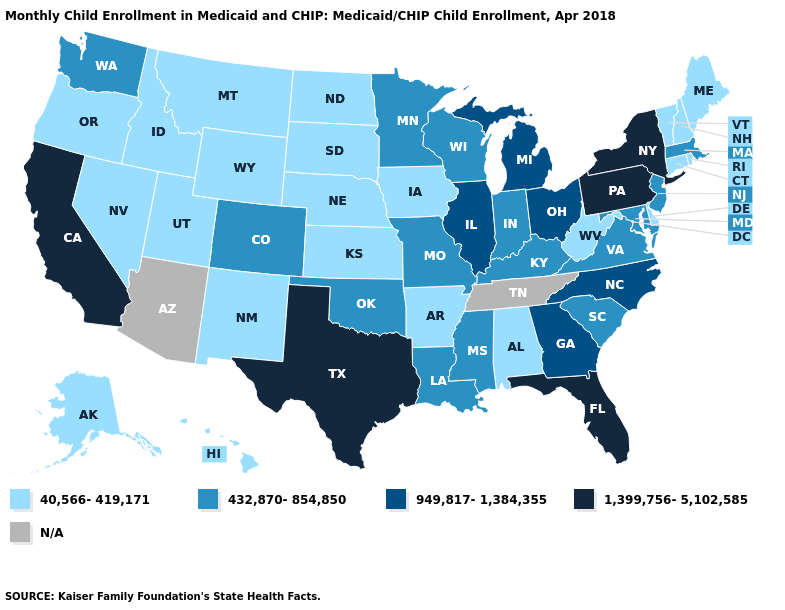Name the states that have a value in the range 40,566-419,171?
Answer briefly. Alabama, Alaska, Arkansas, Connecticut, Delaware, Hawaii, Idaho, Iowa, Kansas, Maine, Montana, Nebraska, Nevada, New Hampshire, New Mexico, North Dakota, Oregon, Rhode Island, South Dakota, Utah, Vermont, West Virginia, Wyoming. What is the value of Nevada?
Answer briefly. 40,566-419,171. Is the legend a continuous bar?
Write a very short answer. No. What is the value of Idaho?
Quick response, please. 40,566-419,171. Name the states that have a value in the range N/A?
Keep it brief. Arizona, Tennessee. Name the states that have a value in the range 949,817-1,384,355?
Keep it brief. Georgia, Illinois, Michigan, North Carolina, Ohio. Does New York have the highest value in the USA?
Quick response, please. Yes. Does New Jersey have the lowest value in the USA?
Concise answer only. No. Is the legend a continuous bar?
Short answer required. No. What is the value of North Carolina?
Concise answer only. 949,817-1,384,355. Does Texas have the highest value in the USA?
Keep it brief. Yes. Does Pennsylvania have the highest value in the USA?
Write a very short answer. Yes. What is the lowest value in states that border Pennsylvania?
Be succinct. 40,566-419,171. Which states have the lowest value in the USA?
Concise answer only. Alabama, Alaska, Arkansas, Connecticut, Delaware, Hawaii, Idaho, Iowa, Kansas, Maine, Montana, Nebraska, Nevada, New Hampshire, New Mexico, North Dakota, Oregon, Rhode Island, South Dakota, Utah, Vermont, West Virginia, Wyoming. 